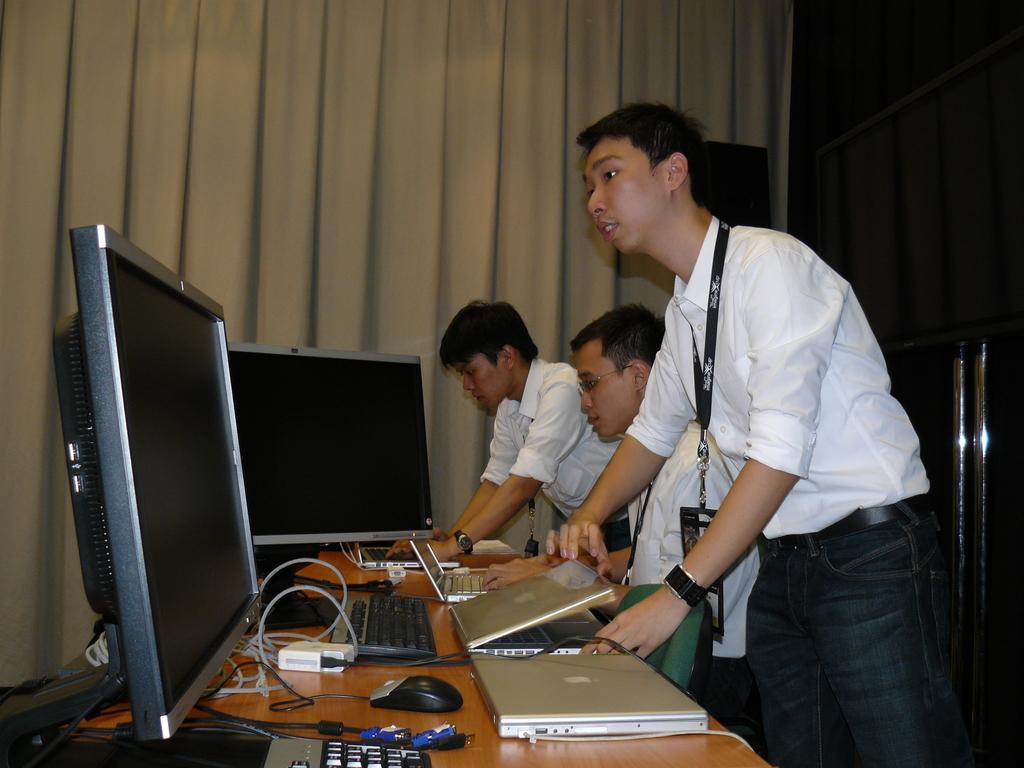Describe this image in one or two sentences. In this image I can see three persons. In front the person is wearing white and black color dress and I can see few laptops, systems on the table. In the background I can see few curtains in cream and black color. 